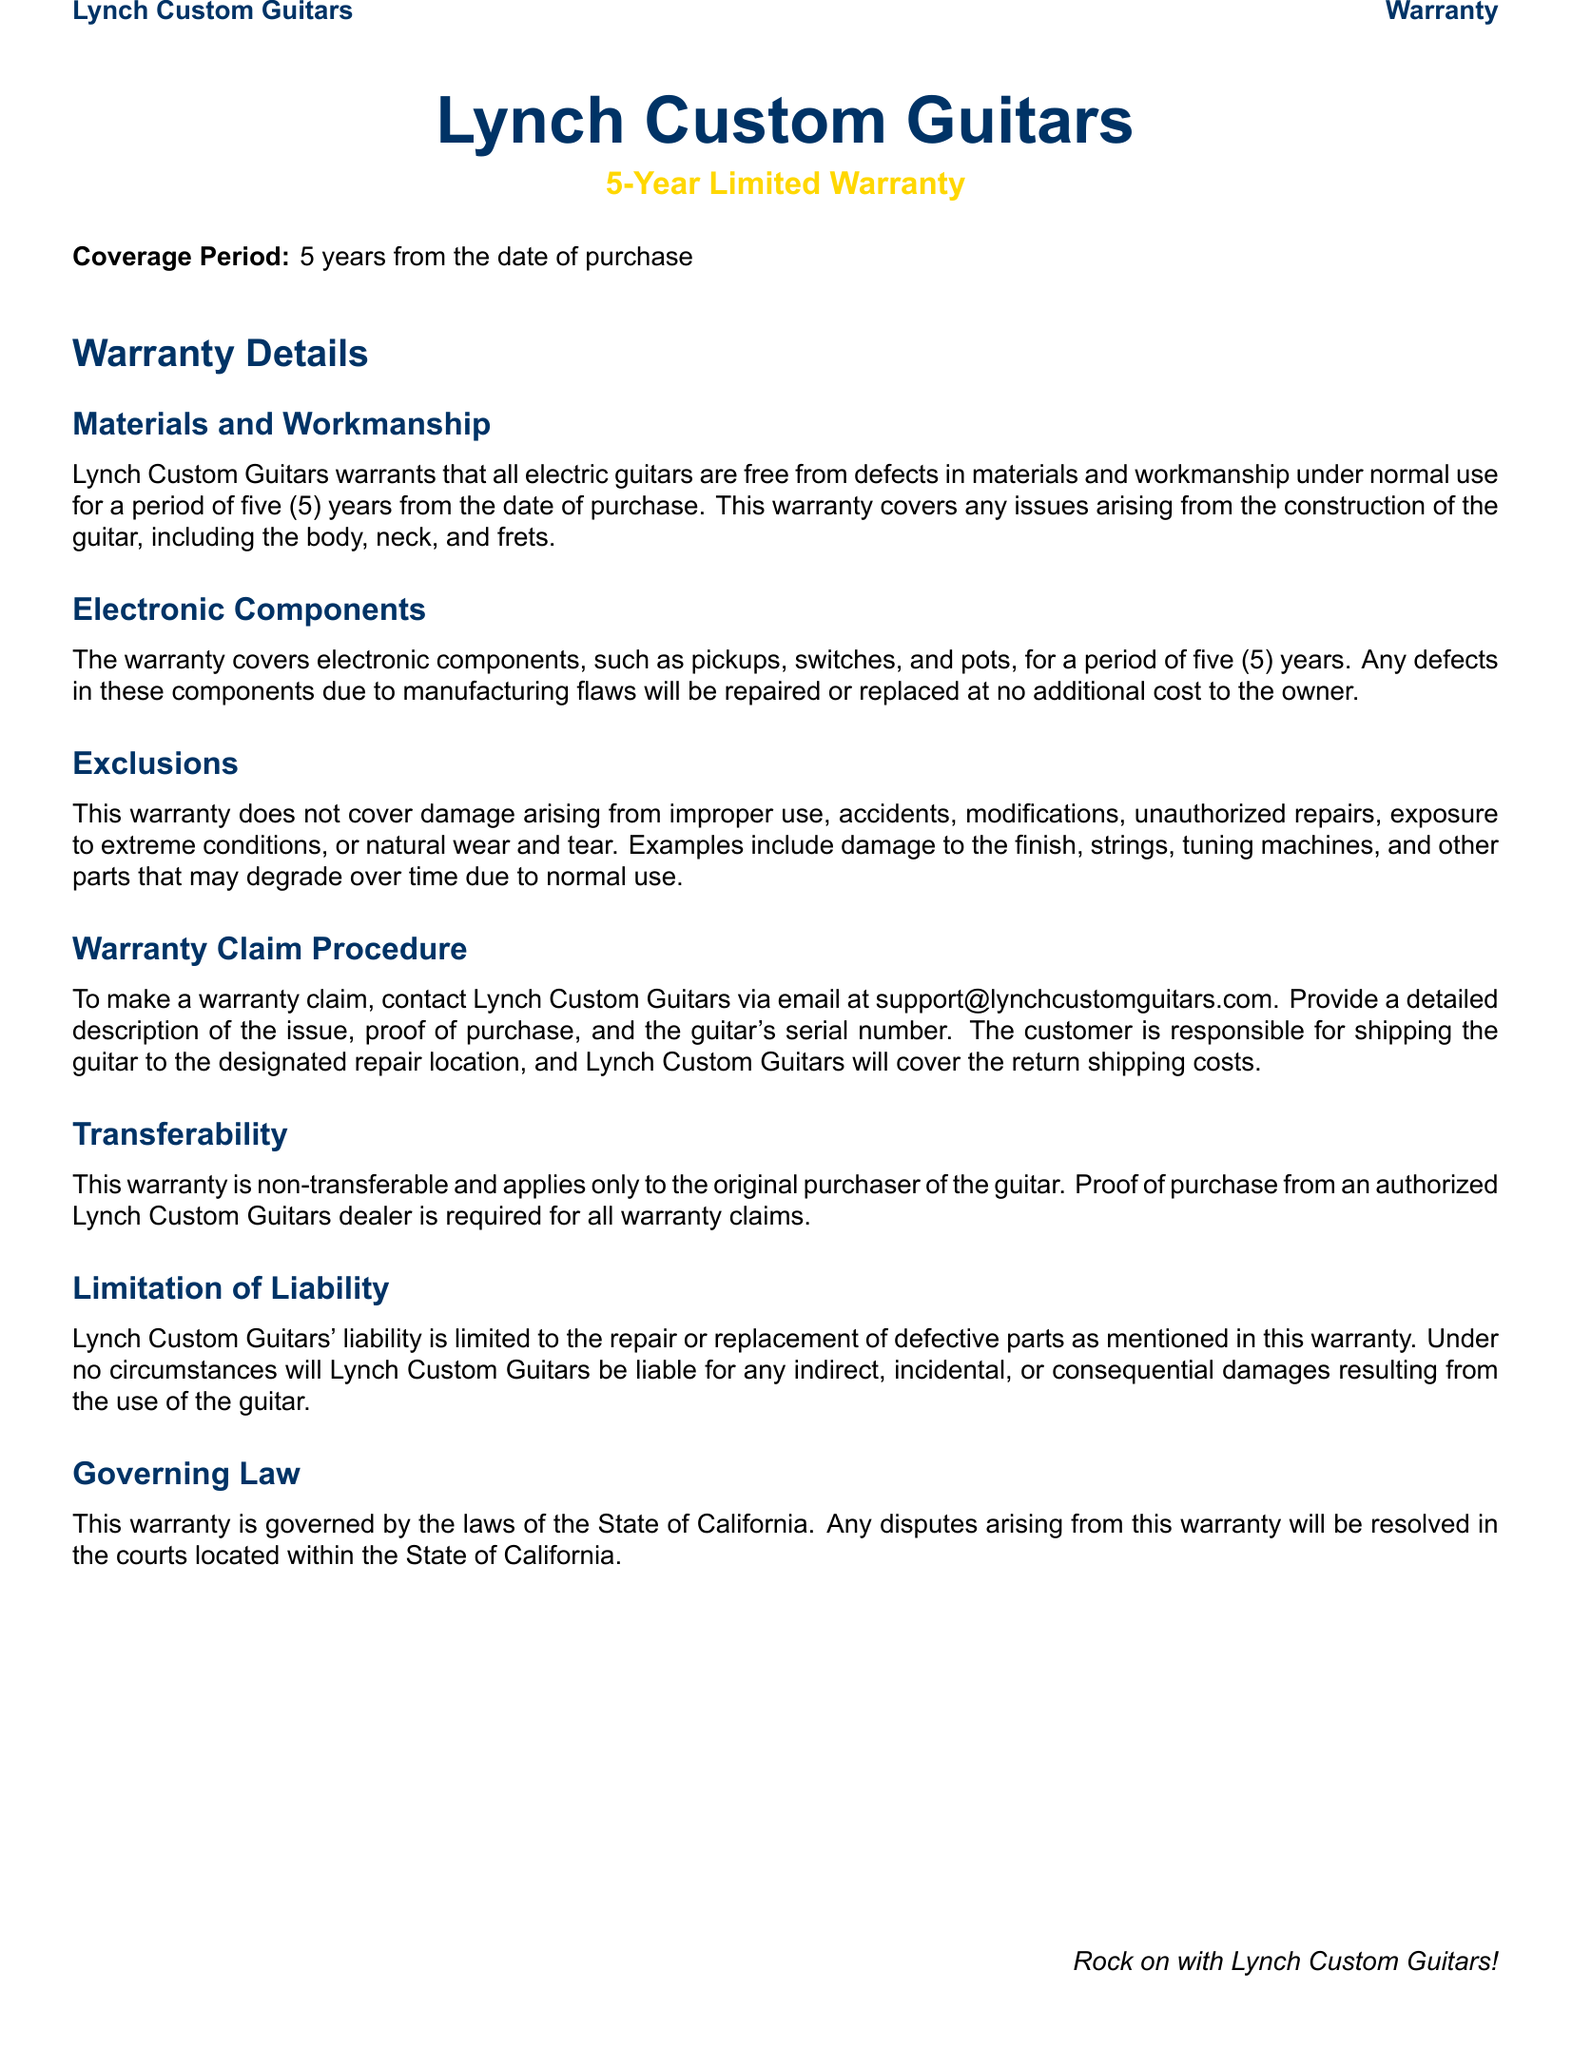What is the coverage period for the warranty? The coverage period is explicitly stated in the document as five years from the date of purchase.
Answer: five years What email should customers use for warranty claims? The document specifies the contact email for warranty claims as support@lynchcustomguitars.com.
Answer: support@lynchcustomguitars.com What is excluded from the warranty coverage? The document lists several exclusions, including damage from improper use and natural wear and tear.
Answer: improper use, accidents, modifications, natural wear and tear Is the warranty transferable? The warranty's transferability clause indicates that it is non-transferable and applies only to the original purchaser.
Answer: non-transferable Who is responsible for shipping costs when making a warranty claim? The document states that customers are responsible for shipping to the repair location, but Lynch Custom Guitars will cover the return shipping costs.
Answer: customer What law governs the warranty? The governing law is mentioned as the laws of the State of California in the document.
Answer: California Which components are covered under the warranty? The warranty covers electric components like pickups, switches, and pots for five years.
Answer: electronic components What must be provided for a warranty claim? The document indicates that proof of purchase and a detailed description of the issue are required for a warranty claim.
Answer: proof of purchase, detailed description 